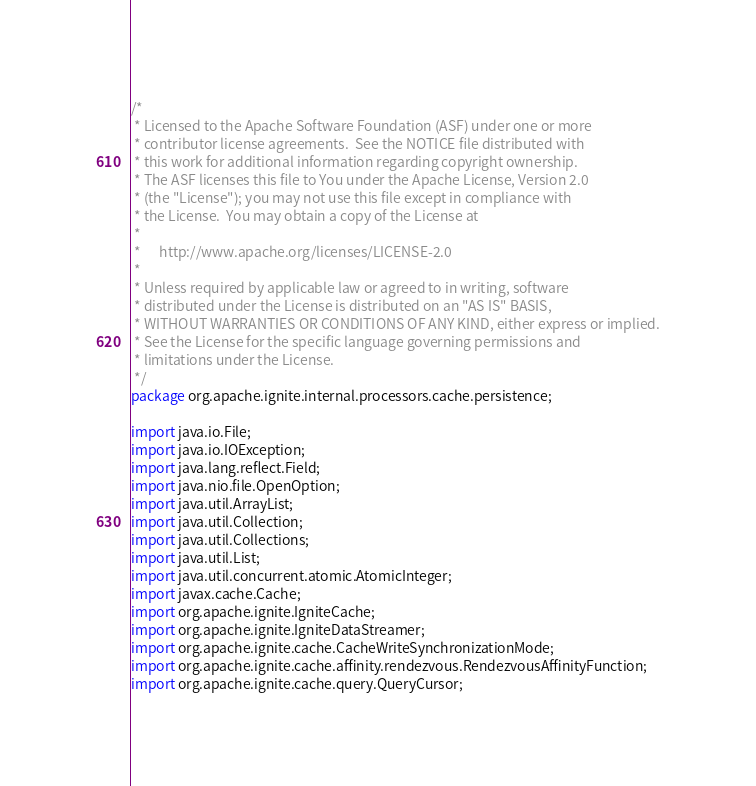Convert code to text. <code><loc_0><loc_0><loc_500><loc_500><_Java_>/*
 * Licensed to the Apache Software Foundation (ASF) under one or more
 * contributor license agreements.  See the NOTICE file distributed with
 * this work for additional information regarding copyright ownership.
 * The ASF licenses this file to You under the Apache License, Version 2.0
 * (the "License"); you may not use this file except in compliance with
 * the License.  You may obtain a copy of the License at
 *
 *      http://www.apache.org/licenses/LICENSE-2.0
 *
 * Unless required by applicable law or agreed to in writing, software
 * distributed under the License is distributed on an "AS IS" BASIS,
 * WITHOUT WARRANTIES OR CONDITIONS OF ANY KIND, either express or implied.
 * See the License for the specific language governing permissions and
 * limitations under the License.
 */
package org.apache.ignite.internal.processors.cache.persistence;

import java.io.File;
import java.io.IOException;
import java.lang.reflect.Field;
import java.nio.file.OpenOption;
import java.util.ArrayList;
import java.util.Collection;
import java.util.Collections;
import java.util.List;
import java.util.concurrent.atomic.AtomicInteger;
import javax.cache.Cache;
import org.apache.ignite.IgniteCache;
import org.apache.ignite.IgniteDataStreamer;
import org.apache.ignite.cache.CacheWriteSynchronizationMode;
import org.apache.ignite.cache.affinity.rendezvous.RendezvousAffinityFunction;
import org.apache.ignite.cache.query.QueryCursor;</code> 